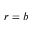Convert formula to latex. <formula><loc_0><loc_0><loc_500><loc_500>r = b</formula> 